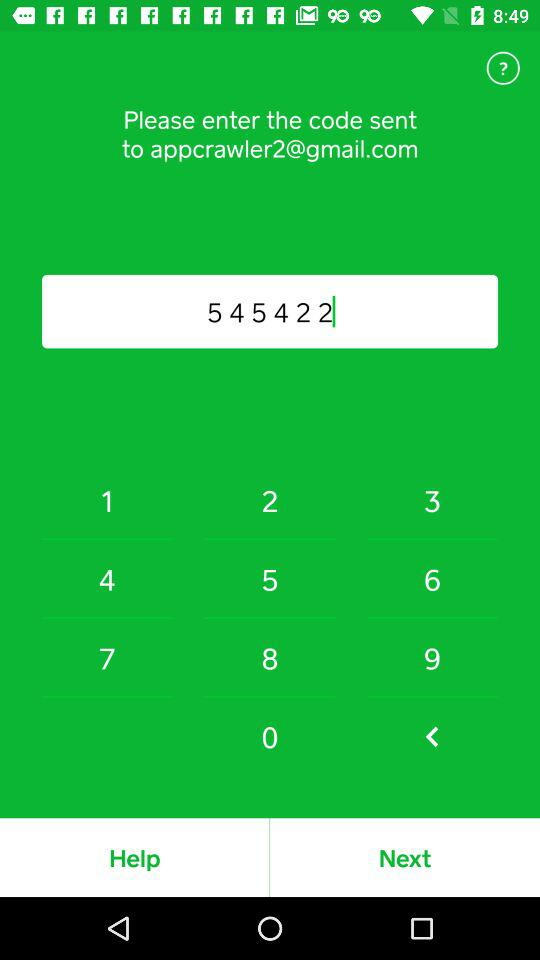What is the code number? The code number is 545422. 